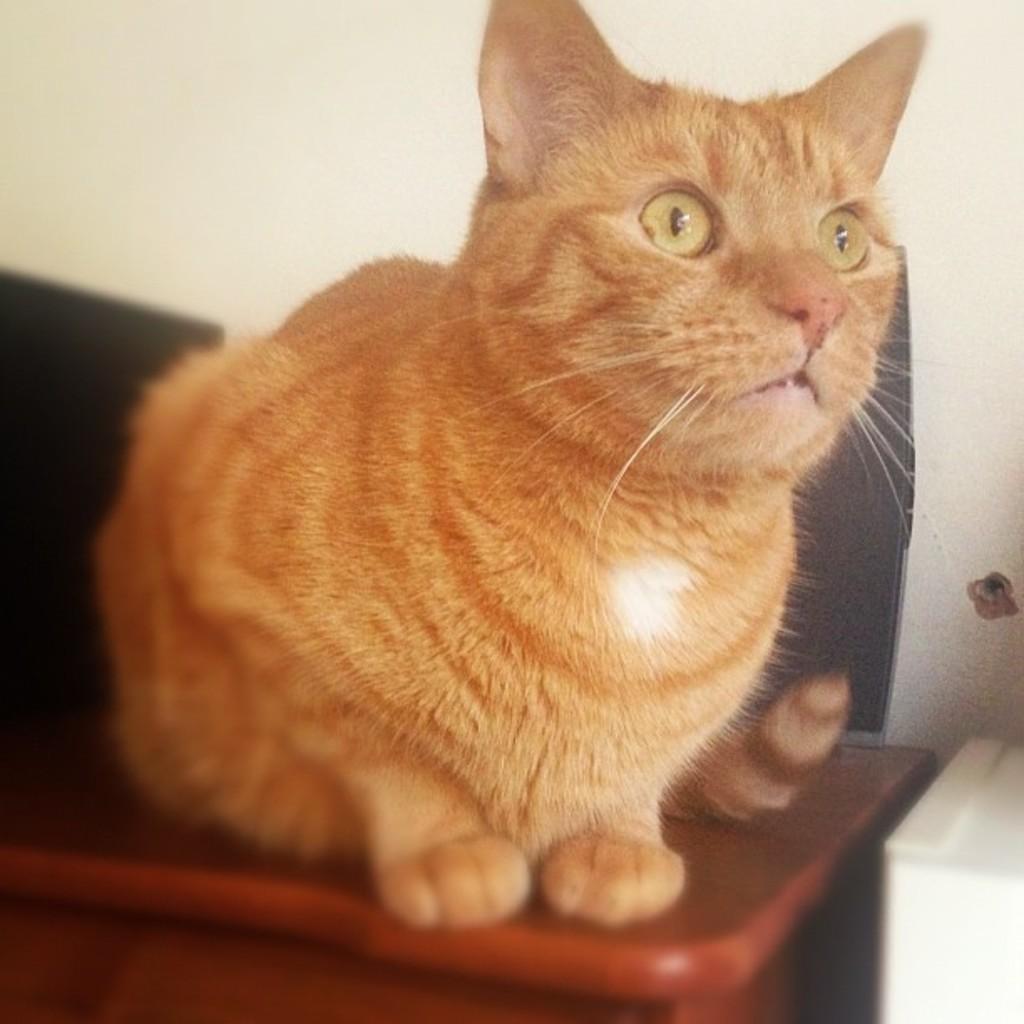How would you summarize this image in a sentence or two? In this image there is a cat on the table. Behind the cat there are black color objects. Beside the table there is some object. In the background of the image there is a wall. 